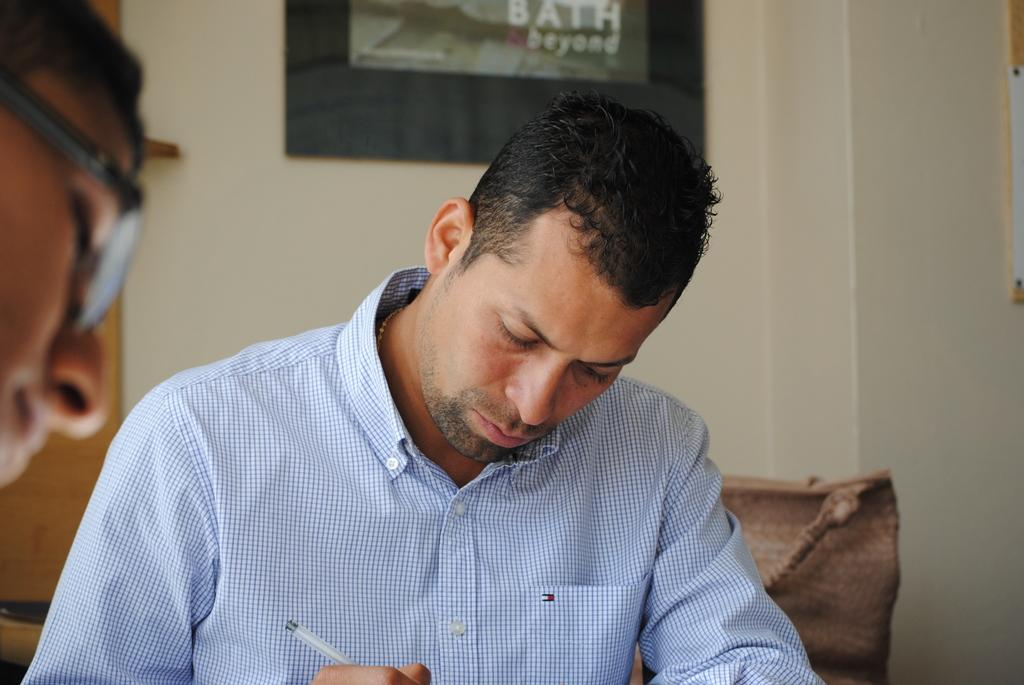What is the person in the image doing? The person is holding a pen and writing something. What object is the person holding while writing? The person is holding a pen. Can you describe the background of the image? There is a photo frame on the wall behind the person. What does the person's mother say about their writing in the image? There is no mention of the person's mother or any dialogue in the image, so it cannot be determined what she might say about their writing. 